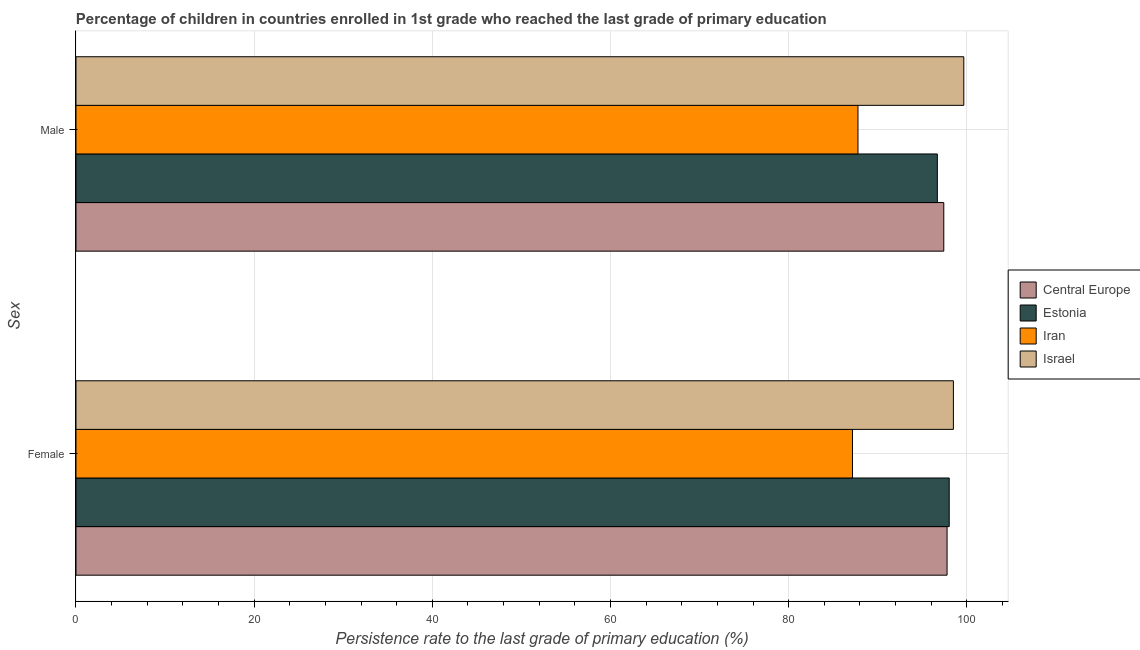How many groups of bars are there?
Make the answer very short. 2. What is the persistence rate of male students in Central Europe?
Your answer should be compact. 97.41. Across all countries, what is the maximum persistence rate of female students?
Ensure brevity in your answer.  98.48. Across all countries, what is the minimum persistence rate of female students?
Your answer should be compact. 87.16. In which country was the persistence rate of male students minimum?
Give a very brief answer. Iran. What is the total persistence rate of male students in the graph?
Your answer should be very brief. 381.52. What is the difference between the persistence rate of male students in Israel and that in Estonia?
Provide a short and direct response. 2.97. What is the difference between the persistence rate of male students in Estonia and the persistence rate of female students in Israel?
Provide a succinct answer. -1.8. What is the average persistence rate of male students per country?
Offer a terse response. 95.38. What is the difference between the persistence rate of male students and persistence rate of female students in Israel?
Offer a very short reply. 1.17. In how many countries, is the persistence rate of female students greater than 16 %?
Your answer should be compact. 4. What is the ratio of the persistence rate of female students in Israel to that in Central Europe?
Your answer should be very brief. 1.01. Is the persistence rate of male students in Israel less than that in Estonia?
Your answer should be compact. No. What does the 2nd bar from the bottom in Male represents?
Keep it short and to the point. Estonia. Are all the bars in the graph horizontal?
Offer a terse response. Yes. How many countries are there in the graph?
Offer a very short reply. 4. How are the legend labels stacked?
Provide a short and direct response. Vertical. What is the title of the graph?
Your response must be concise. Percentage of children in countries enrolled in 1st grade who reached the last grade of primary education. Does "Tunisia" appear as one of the legend labels in the graph?
Ensure brevity in your answer.  No. What is the label or title of the X-axis?
Give a very brief answer. Persistence rate to the last grade of primary education (%). What is the label or title of the Y-axis?
Keep it short and to the point. Sex. What is the Persistence rate to the last grade of primary education (%) in Central Europe in Female?
Your response must be concise. 97.77. What is the Persistence rate to the last grade of primary education (%) in Estonia in Female?
Give a very brief answer. 98.02. What is the Persistence rate to the last grade of primary education (%) in Iran in Female?
Your response must be concise. 87.16. What is the Persistence rate to the last grade of primary education (%) in Israel in Female?
Your response must be concise. 98.48. What is the Persistence rate to the last grade of primary education (%) in Central Europe in Male?
Keep it short and to the point. 97.41. What is the Persistence rate to the last grade of primary education (%) of Estonia in Male?
Provide a short and direct response. 96.68. What is the Persistence rate to the last grade of primary education (%) of Iran in Male?
Make the answer very short. 87.78. What is the Persistence rate to the last grade of primary education (%) in Israel in Male?
Keep it short and to the point. 99.65. Across all Sex, what is the maximum Persistence rate to the last grade of primary education (%) in Central Europe?
Give a very brief answer. 97.77. Across all Sex, what is the maximum Persistence rate to the last grade of primary education (%) in Estonia?
Provide a short and direct response. 98.02. Across all Sex, what is the maximum Persistence rate to the last grade of primary education (%) in Iran?
Your response must be concise. 87.78. Across all Sex, what is the maximum Persistence rate to the last grade of primary education (%) in Israel?
Ensure brevity in your answer.  99.65. Across all Sex, what is the minimum Persistence rate to the last grade of primary education (%) in Central Europe?
Your answer should be very brief. 97.41. Across all Sex, what is the minimum Persistence rate to the last grade of primary education (%) of Estonia?
Provide a short and direct response. 96.68. Across all Sex, what is the minimum Persistence rate to the last grade of primary education (%) of Iran?
Offer a terse response. 87.16. Across all Sex, what is the minimum Persistence rate to the last grade of primary education (%) of Israel?
Your answer should be very brief. 98.48. What is the total Persistence rate to the last grade of primary education (%) of Central Europe in the graph?
Give a very brief answer. 195.18. What is the total Persistence rate to the last grade of primary education (%) in Estonia in the graph?
Ensure brevity in your answer.  194.7. What is the total Persistence rate to the last grade of primary education (%) in Iran in the graph?
Make the answer very short. 174.94. What is the total Persistence rate to the last grade of primary education (%) in Israel in the graph?
Make the answer very short. 198.14. What is the difference between the Persistence rate to the last grade of primary education (%) of Central Europe in Female and that in Male?
Offer a very short reply. 0.37. What is the difference between the Persistence rate to the last grade of primary education (%) of Estonia in Female and that in Male?
Keep it short and to the point. 1.33. What is the difference between the Persistence rate to the last grade of primary education (%) in Iran in Female and that in Male?
Offer a very short reply. -0.61. What is the difference between the Persistence rate to the last grade of primary education (%) in Israel in Female and that in Male?
Provide a short and direct response. -1.17. What is the difference between the Persistence rate to the last grade of primary education (%) in Central Europe in Female and the Persistence rate to the last grade of primary education (%) in Estonia in Male?
Provide a succinct answer. 1.09. What is the difference between the Persistence rate to the last grade of primary education (%) in Central Europe in Female and the Persistence rate to the last grade of primary education (%) in Iran in Male?
Your response must be concise. 10. What is the difference between the Persistence rate to the last grade of primary education (%) of Central Europe in Female and the Persistence rate to the last grade of primary education (%) of Israel in Male?
Your answer should be very brief. -1.88. What is the difference between the Persistence rate to the last grade of primary education (%) of Estonia in Female and the Persistence rate to the last grade of primary education (%) of Iran in Male?
Make the answer very short. 10.24. What is the difference between the Persistence rate to the last grade of primary education (%) in Estonia in Female and the Persistence rate to the last grade of primary education (%) in Israel in Male?
Your response must be concise. -1.64. What is the difference between the Persistence rate to the last grade of primary education (%) of Iran in Female and the Persistence rate to the last grade of primary education (%) of Israel in Male?
Give a very brief answer. -12.49. What is the average Persistence rate to the last grade of primary education (%) in Central Europe per Sex?
Offer a terse response. 97.59. What is the average Persistence rate to the last grade of primary education (%) in Estonia per Sex?
Your answer should be compact. 97.35. What is the average Persistence rate to the last grade of primary education (%) of Iran per Sex?
Your answer should be very brief. 87.47. What is the average Persistence rate to the last grade of primary education (%) in Israel per Sex?
Provide a short and direct response. 99.07. What is the difference between the Persistence rate to the last grade of primary education (%) in Central Europe and Persistence rate to the last grade of primary education (%) in Estonia in Female?
Provide a short and direct response. -0.24. What is the difference between the Persistence rate to the last grade of primary education (%) of Central Europe and Persistence rate to the last grade of primary education (%) of Iran in Female?
Offer a terse response. 10.61. What is the difference between the Persistence rate to the last grade of primary education (%) of Central Europe and Persistence rate to the last grade of primary education (%) of Israel in Female?
Provide a short and direct response. -0.71. What is the difference between the Persistence rate to the last grade of primary education (%) of Estonia and Persistence rate to the last grade of primary education (%) of Iran in Female?
Provide a short and direct response. 10.85. What is the difference between the Persistence rate to the last grade of primary education (%) of Estonia and Persistence rate to the last grade of primary education (%) of Israel in Female?
Give a very brief answer. -0.47. What is the difference between the Persistence rate to the last grade of primary education (%) of Iran and Persistence rate to the last grade of primary education (%) of Israel in Female?
Ensure brevity in your answer.  -11.32. What is the difference between the Persistence rate to the last grade of primary education (%) of Central Europe and Persistence rate to the last grade of primary education (%) of Estonia in Male?
Your answer should be compact. 0.72. What is the difference between the Persistence rate to the last grade of primary education (%) in Central Europe and Persistence rate to the last grade of primary education (%) in Iran in Male?
Give a very brief answer. 9.63. What is the difference between the Persistence rate to the last grade of primary education (%) in Central Europe and Persistence rate to the last grade of primary education (%) in Israel in Male?
Keep it short and to the point. -2.25. What is the difference between the Persistence rate to the last grade of primary education (%) of Estonia and Persistence rate to the last grade of primary education (%) of Iran in Male?
Ensure brevity in your answer.  8.91. What is the difference between the Persistence rate to the last grade of primary education (%) in Estonia and Persistence rate to the last grade of primary education (%) in Israel in Male?
Keep it short and to the point. -2.97. What is the difference between the Persistence rate to the last grade of primary education (%) of Iran and Persistence rate to the last grade of primary education (%) of Israel in Male?
Ensure brevity in your answer.  -11.88. What is the ratio of the Persistence rate to the last grade of primary education (%) of Central Europe in Female to that in Male?
Offer a terse response. 1. What is the ratio of the Persistence rate to the last grade of primary education (%) of Estonia in Female to that in Male?
Provide a succinct answer. 1.01. What is the ratio of the Persistence rate to the last grade of primary education (%) in Israel in Female to that in Male?
Make the answer very short. 0.99. What is the difference between the highest and the second highest Persistence rate to the last grade of primary education (%) of Central Europe?
Keep it short and to the point. 0.37. What is the difference between the highest and the second highest Persistence rate to the last grade of primary education (%) in Estonia?
Keep it short and to the point. 1.33. What is the difference between the highest and the second highest Persistence rate to the last grade of primary education (%) of Iran?
Your response must be concise. 0.61. What is the difference between the highest and the second highest Persistence rate to the last grade of primary education (%) in Israel?
Provide a short and direct response. 1.17. What is the difference between the highest and the lowest Persistence rate to the last grade of primary education (%) of Central Europe?
Offer a terse response. 0.37. What is the difference between the highest and the lowest Persistence rate to the last grade of primary education (%) in Estonia?
Offer a very short reply. 1.33. What is the difference between the highest and the lowest Persistence rate to the last grade of primary education (%) in Iran?
Ensure brevity in your answer.  0.61. What is the difference between the highest and the lowest Persistence rate to the last grade of primary education (%) in Israel?
Give a very brief answer. 1.17. 